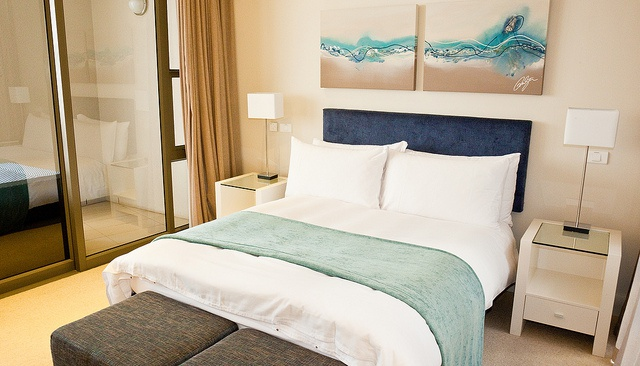Describe the objects in this image and their specific colors. I can see a bed in tan, lightgray, darkgray, and black tones in this image. 